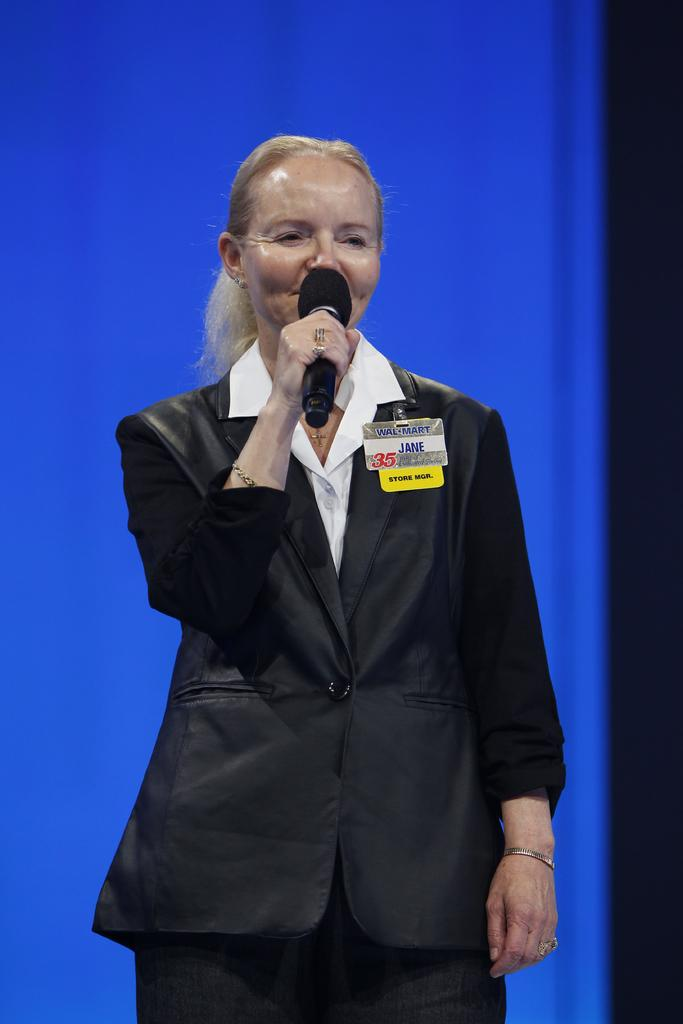Who is the main subject in the image? There is a woman in the image. What is the woman doing in the image? The woman is standing and appears to be talking. What is the woman holding in the image? The woman is holding a mic in the image. What is the color of the background in the image? The background of the image is blue in color. Can you see any mountains or stamps in the image? No, there are no mountains, stamps, or powder visible in the image. 